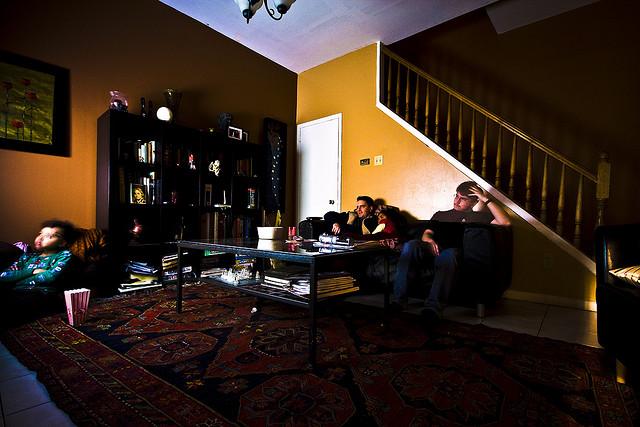Where is the light in the room coming from?
Keep it brief. Television. What color is the wall?
Short answer required. Orange. Is there a ceiling light?
Write a very short answer. Yes. What are the people drinking?
Quick response, please. Soda. 